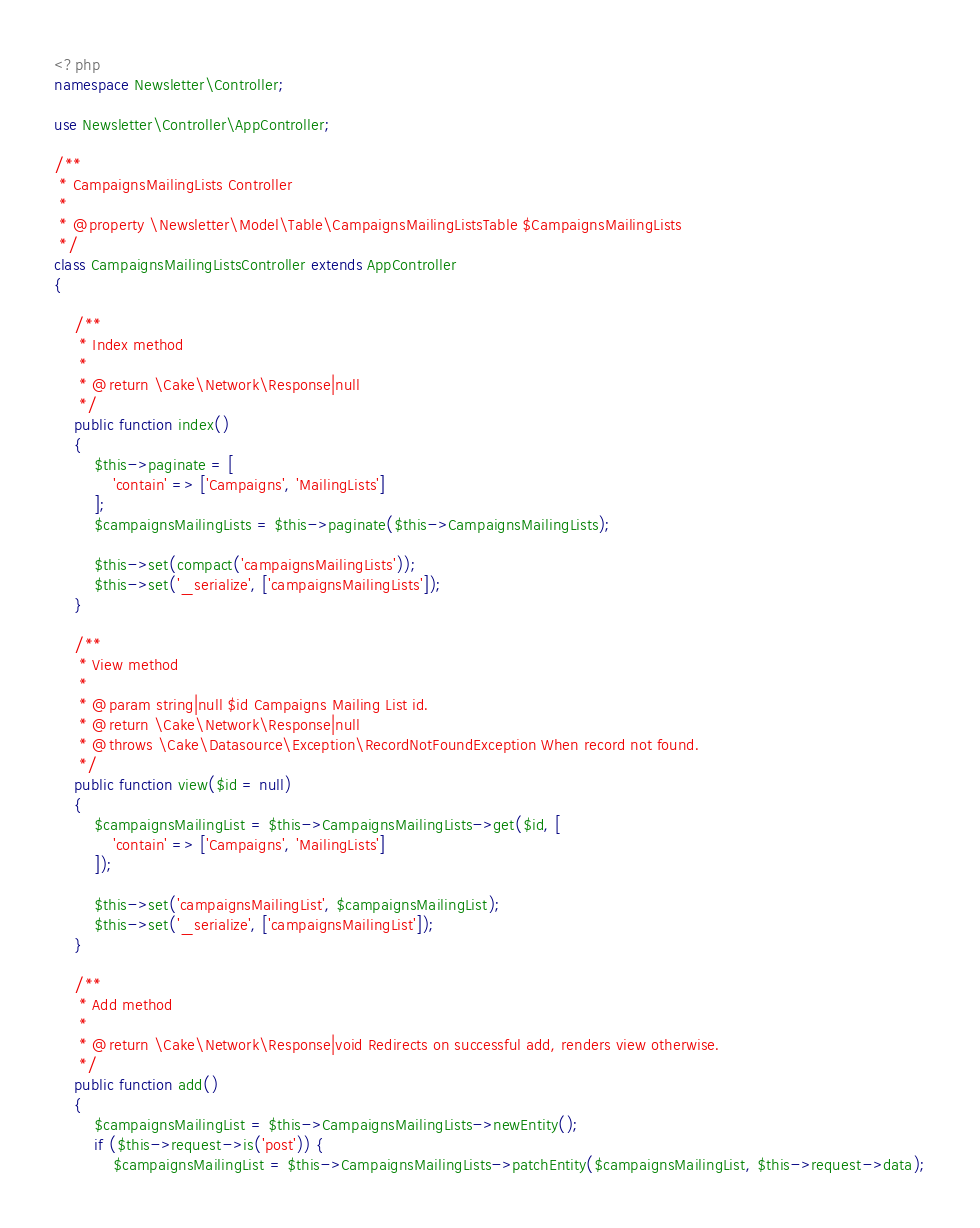<code> <loc_0><loc_0><loc_500><loc_500><_PHP_><?php
namespace Newsletter\Controller;

use Newsletter\Controller\AppController;

/**
 * CampaignsMailingLists Controller
 *
 * @property \Newsletter\Model\Table\CampaignsMailingListsTable $CampaignsMailingLists
 */
class CampaignsMailingListsController extends AppController
{

    /**
     * Index method
     *
     * @return \Cake\Network\Response|null
     */
    public function index()
    {
        $this->paginate = [
            'contain' => ['Campaigns', 'MailingLists']
        ];
        $campaignsMailingLists = $this->paginate($this->CampaignsMailingLists);

        $this->set(compact('campaignsMailingLists'));
        $this->set('_serialize', ['campaignsMailingLists']);
    }

    /**
     * View method
     *
     * @param string|null $id Campaigns Mailing List id.
     * @return \Cake\Network\Response|null
     * @throws \Cake\Datasource\Exception\RecordNotFoundException When record not found.
     */
    public function view($id = null)
    {
        $campaignsMailingList = $this->CampaignsMailingLists->get($id, [
            'contain' => ['Campaigns', 'MailingLists']
        ]);

        $this->set('campaignsMailingList', $campaignsMailingList);
        $this->set('_serialize', ['campaignsMailingList']);
    }

    /**
     * Add method
     *
     * @return \Cake\Network\Response|void Redirects on successful add, renders view otherwise.
     */
    public function add()
    {
        $campaignsMailingList = $this->CampaignsMailingLists->newEntity();
        if ($this->request->is('post')) {
            $campaignsMailingList = $this->CampaignsMailingLists->patchEntity($campaignsMailingList, $this->request->data);</code> 